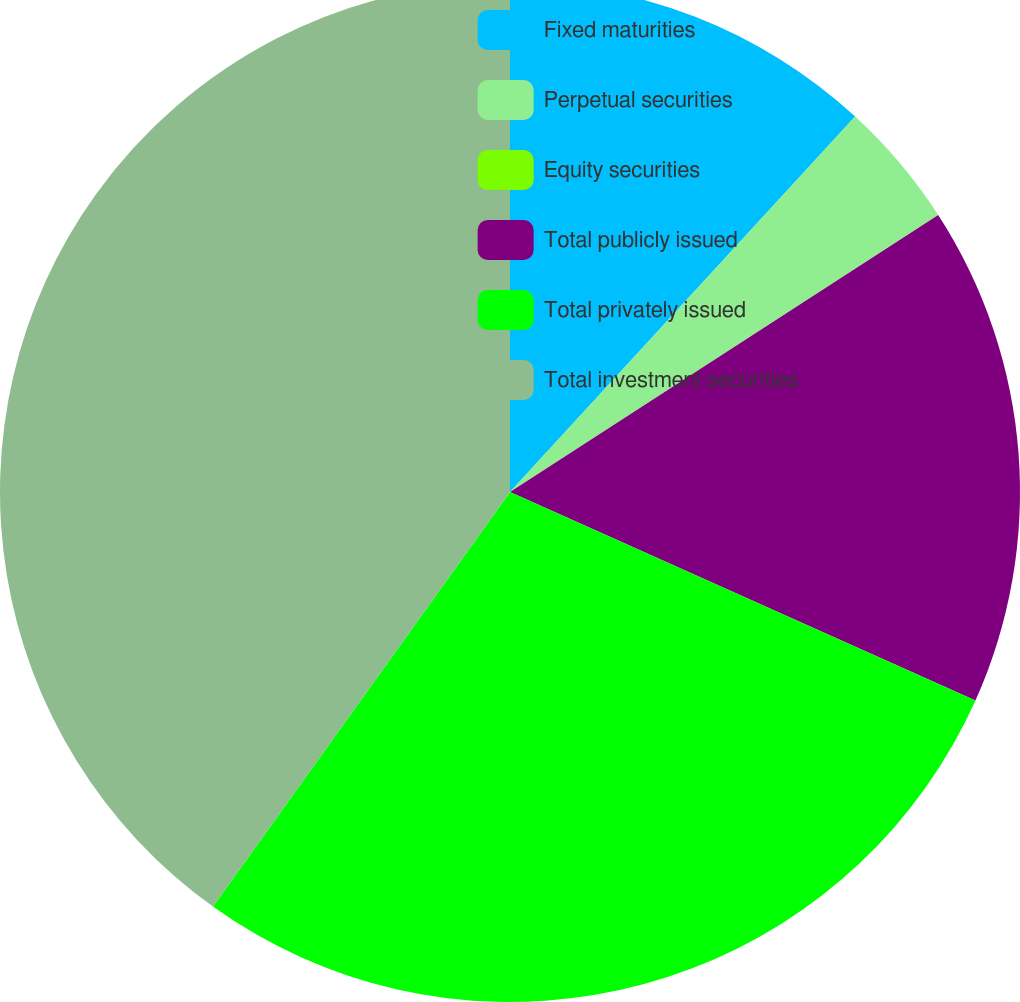Convert chart. <chart><loc_0><loc_0><loc_500><loc_500><pie_chart><fcel>Fixed maturities<fcel>Perpetual securities<fcel>Equity securities<fcel>Total publicly issued<fcel>Total privately issued<fcel>Total investment securities<nl><fcel>11.83%<fcel>4.02%<fcel>0.01%<fcel>15.84%<fcel>28.19%<fcel>40.1%<nl></chart> 